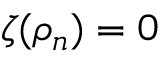<formula> <loc_0><loc_0><loc_500><loc_500>\zeta ( \rho _ { n } ) = 0</formula> 